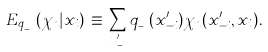Convert formula to latex. <formula><loc_0><loc_0><loc_500><loc_500>E _ { q _ { _ { - i } } } ( \chi _ { n } | x _ { i } ) \, \equiv \, \sum _ { x ^ { \prime } _ { _ { - i } } } q _ { _ { - i } } ( x ^ { \prime } _ { - i } ) \chi _ { n } ( x ^ { \prime } _ { - i } , x _ { i } ) .</formula> 